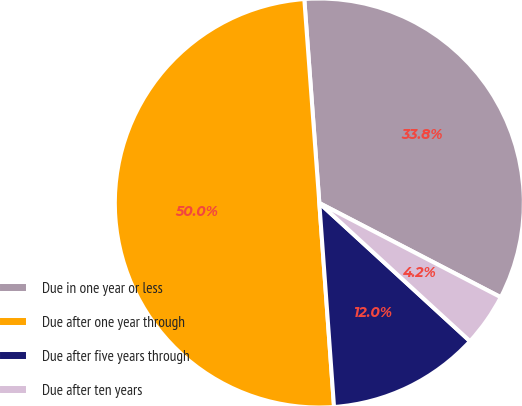Convert chart to OTSL. <chart><loc_0><loc_0><loc_500><loc_500><pie_chart><fcel>Due in one year or less<fcel>Due after one year through<fcel>Due after five years through<fcel>Due after ten years<nl><fcel>33.79%<fcel>49.97%<fcel>12.04%<fcel>4.19%<nl></chart> 